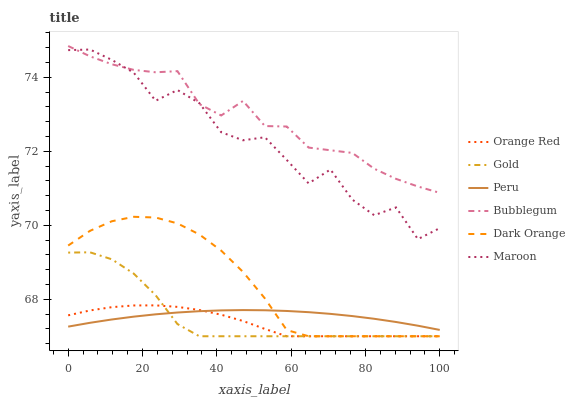Does Orange Red have the minimum area under the curve?
Answer yes or no. Yes. Does Bubblegum have the maximum area under the curve?
Answer yes or no. Yes. Does Gold have the minimum area under the curve?
Answer yes or no. No. Does Gold have the maximum area under the curve?
Answer yes or no. No. Is Peru the smoothest?
Answer yes or no. Yes. Is Maroon the roughest?
Answer yes or no. Yes. Is Gold the smoothest?
Answer yes or no. No. Is Gold the roughest?
Answer yes or no. No. Does Maroon have the lowest value?
Answer yes or no. No. Does Bubblegum have the highest value?
Answer yes or no. Yes. Does Gold have the highest value?
Answer yes or no. No. Is Peru less than Bubblegum?
Answer yes or no. Yes. Is Bubblegum greater than Gold?
Answer yes or no. Yes. Does Orange Red intersect Peru?
Answer yes or no. Yes. Is Orange Red less than Peru?
Answer yes or no. No. Is Orange Red greater than Peru?
Answer yes or no. No. Does Peru intersect Bubblegum?
Answer yes or no. No. 